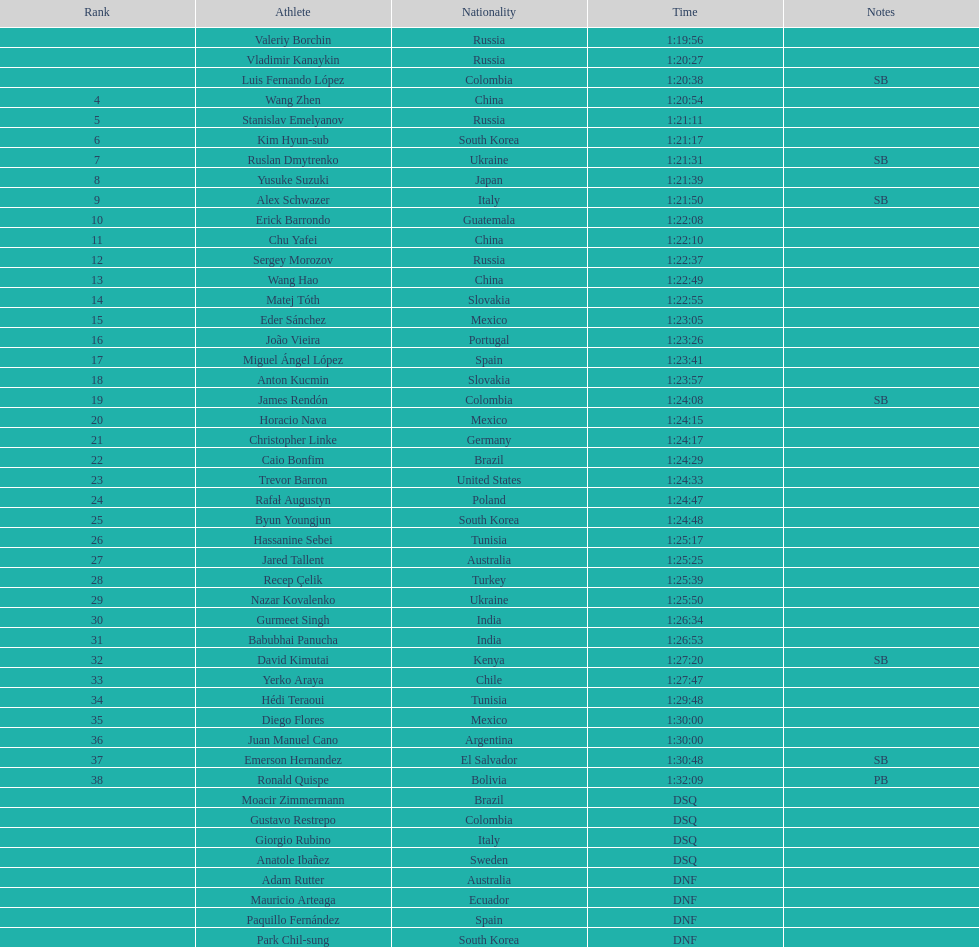Which competitor was positioned first? Valeriy Borchin. 